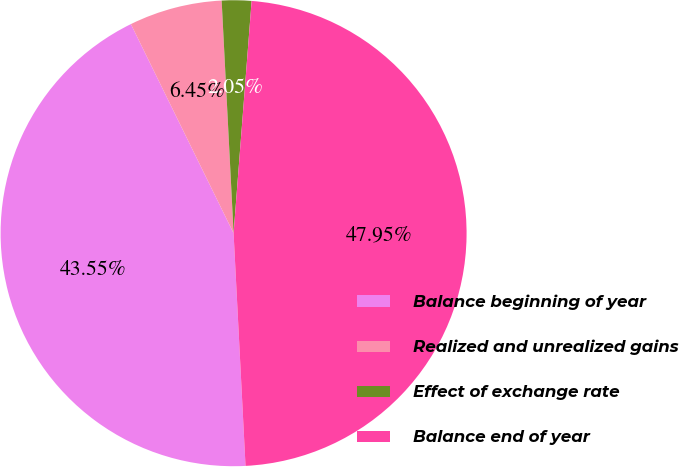Convert chart to OTSL. <chart><loc_0><loc_0><loc_500><loc_500><pie_chart><fcel>Balance beginning of year<fcel>Realized and unrealized gains<fcel>Effect of exchange rate<fcel>Balance end of year<nl><fcel>43.55%<fcel>6.45%<fcel>2.05%<fcel>47.95%<nl></chart> 